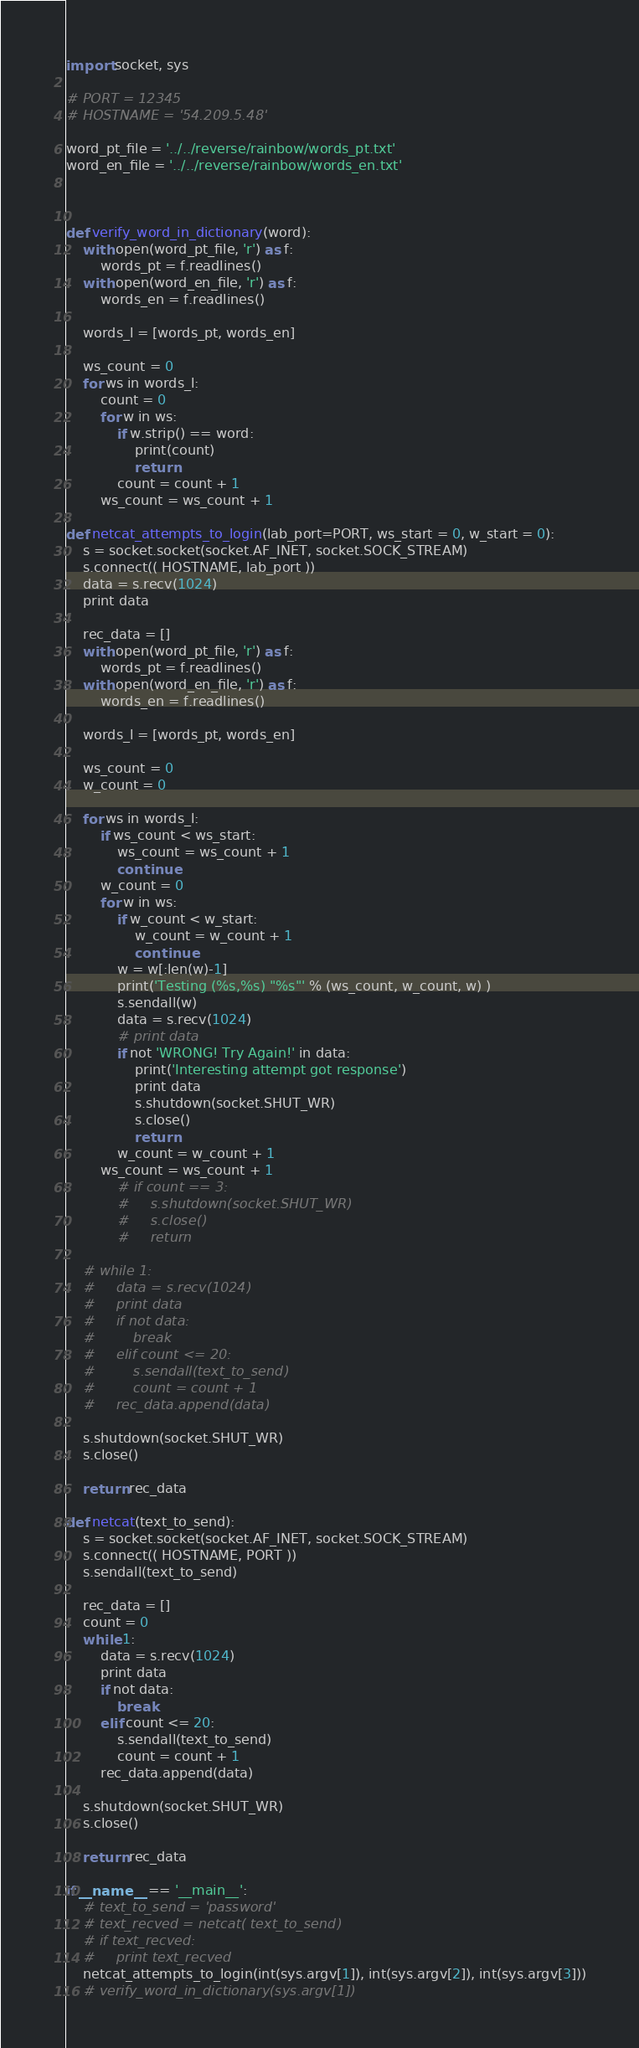Convert code to text. <code><loc_0><loc_0><loc_500><loc_500><_Python_>import socket, sys

# PORT = 12345
# HOSTNAME = '54.209.5.48'

word_pt_file = '../../reverse/rainbow/words_pt.txt'
word_en_file = '../../reverse/rainbow/words_en.txt'



def verify_word_in_dictionary(word):
    with open(word_pt_file, 'r') as f:
        words_pt = f.readlines()
    with open(word_en_file, 'r') as f:
        words_en = f.readlines()

    words_l = [words_pt, words_en]

    ws_count = 0
    for ws in words_l:
        count = 0
        for w in ws:
            if w.strip() == word:
                print(count)
                return
            count = count + 1
        ws_count = ws_count + 1

def netcat_attempts_to_login(lab_port=PORT, ws_start = 0, w_start = 0):
    s = socket.socket(socket.AF_INET, socket.SOCK_STREAM)
    s.connect(( HOSTNAME, lab_port ))
    data = s.recv(1024)
    print data

    rec_data = []
    with open(word_pt_file, 'r') as f:
        words_pt = f.readlines()
    with open(word_en_file, 'r') as f:
        words_en = f.readlines()

    words_l = [words_pt, words_en]

    ws_count = 0
    w_count = 0

    for ws in words_l:
        if ws_count < ws_start:
            ws_count = ws_count + 1
            continue
        w_count = 0
        for w in ws:
            if w_count < w_start:
                w_count = w_count + 1
                continue
            w = w[:len(w)-1]
            print('Testing (%s,%s) "%s"' % (ws_count, w_count, w) )
            s.sendall(w)
            data = s.recv(1024)
            # print data
            if not 'WRONG! Try Again!' in data:
                print('Interesting attempt got response')
                print data
                s.shutdown(socket.SHUT_WR)
                s.close()
                return
            w_count = w_count + 1
        ws_count = ws_count + 1
            # if count == 3:
            #     s.shutdown(socket.SHUT_WR)
            #     s.close()
            #     return

    # while 1:
    #     data = s.recv(1024)
    #     print data
    #     if not data:
    #         break
    #     elif count <= 20:
    #         s.sendall(text_to_send)
    #         count = count + 1
    #     rec_data.append(data)

    s.shutdown(socket.SHUT_WR)
    s.close()

    return rec_data

def netcat(text_to_send):
    s = socket.socket(socket.AF_INET, socket.SOCK_STREAM)
    s.connect(( HOSTNAME, PORT ))
    s.sendall(text_to_send)

    rec_data = []
    count = 0
    while 1:
        data = s.recv(1024)
        print data
        if not data:
            break
        elif count <= 20:
            s.sendall(text_to_send)
            count = count + 1
        rec_data.append(data)

    s.shutdown(socket.SHUT_WR)
    s.close()

    return rec_data

if __name__ == '__main__':
    # text_to_send = 'password'
    # text_recved = netcat( text_to_send)
    # if text_recved:
    #     print text_recved
    netcat_attempts_to_login(int(sys.argv[1]), int(sys.argv[2]), int(sys.argv[3]))
    # verify_word_in_dictionary(sys.argv[1])</code> 